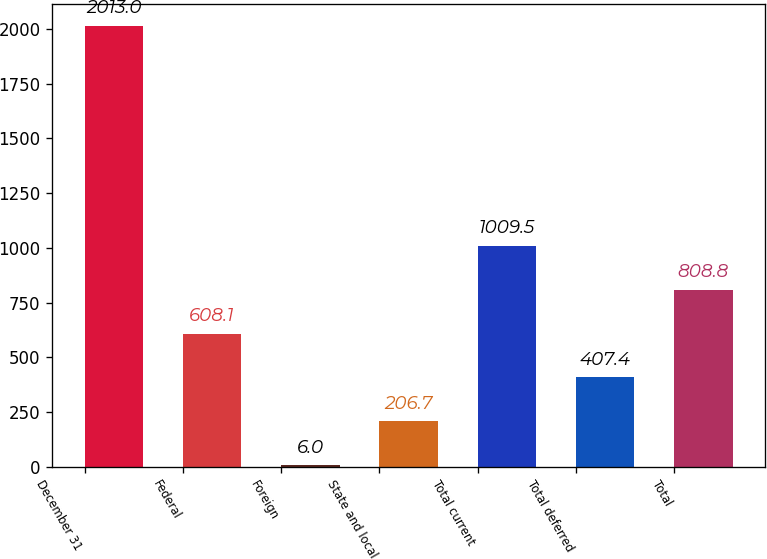<chart> <loc_0><loc_0><loc_500><loc_500><bar_chart><fcel>December 31<fcel>Federal<fcel>Foreign<fcel>State and local<fcel>Total current<fcel>Total deferred<fcel>Total<nl><fcel>2013<fcel>608.1<fcel>6<fcel>206.7<fcel>1009.5<fcel>407.4<fcel>808.8<nl></chart> 